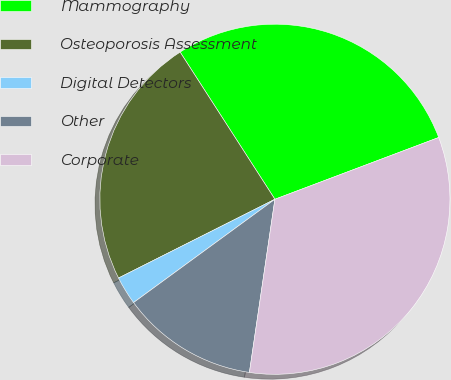<chart> <loc_0><loc_0><loc_500><loc_500><pie_chart><fcel>Mammography<fcel>Osteoporosis Assessment<fcel>Digital Detectors<fcel>Other<fcel>Corporate<nl><fcel>28.37%<fcel>23.32%<fcel>2.62%<fcel>12.63%<fcel>33.07%<nl></chart> 